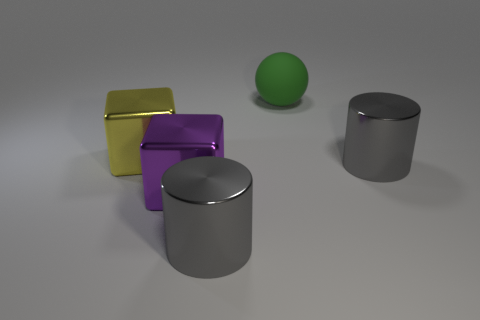Add 4 gray objects. How many objects exist? 9 Subtract all cubes. How many objects are left? 3 Add 3 green rubber blocks. How many green rubber blocks exist? 3 Subtract 0 purple cylinders. How many objects are left? 5 Subtract all yellow metallic things. Subtract all big green matte spheres. How many objects are left? 3 Add 3 gray metallic objects. How many gray metallic objects are left? 5 